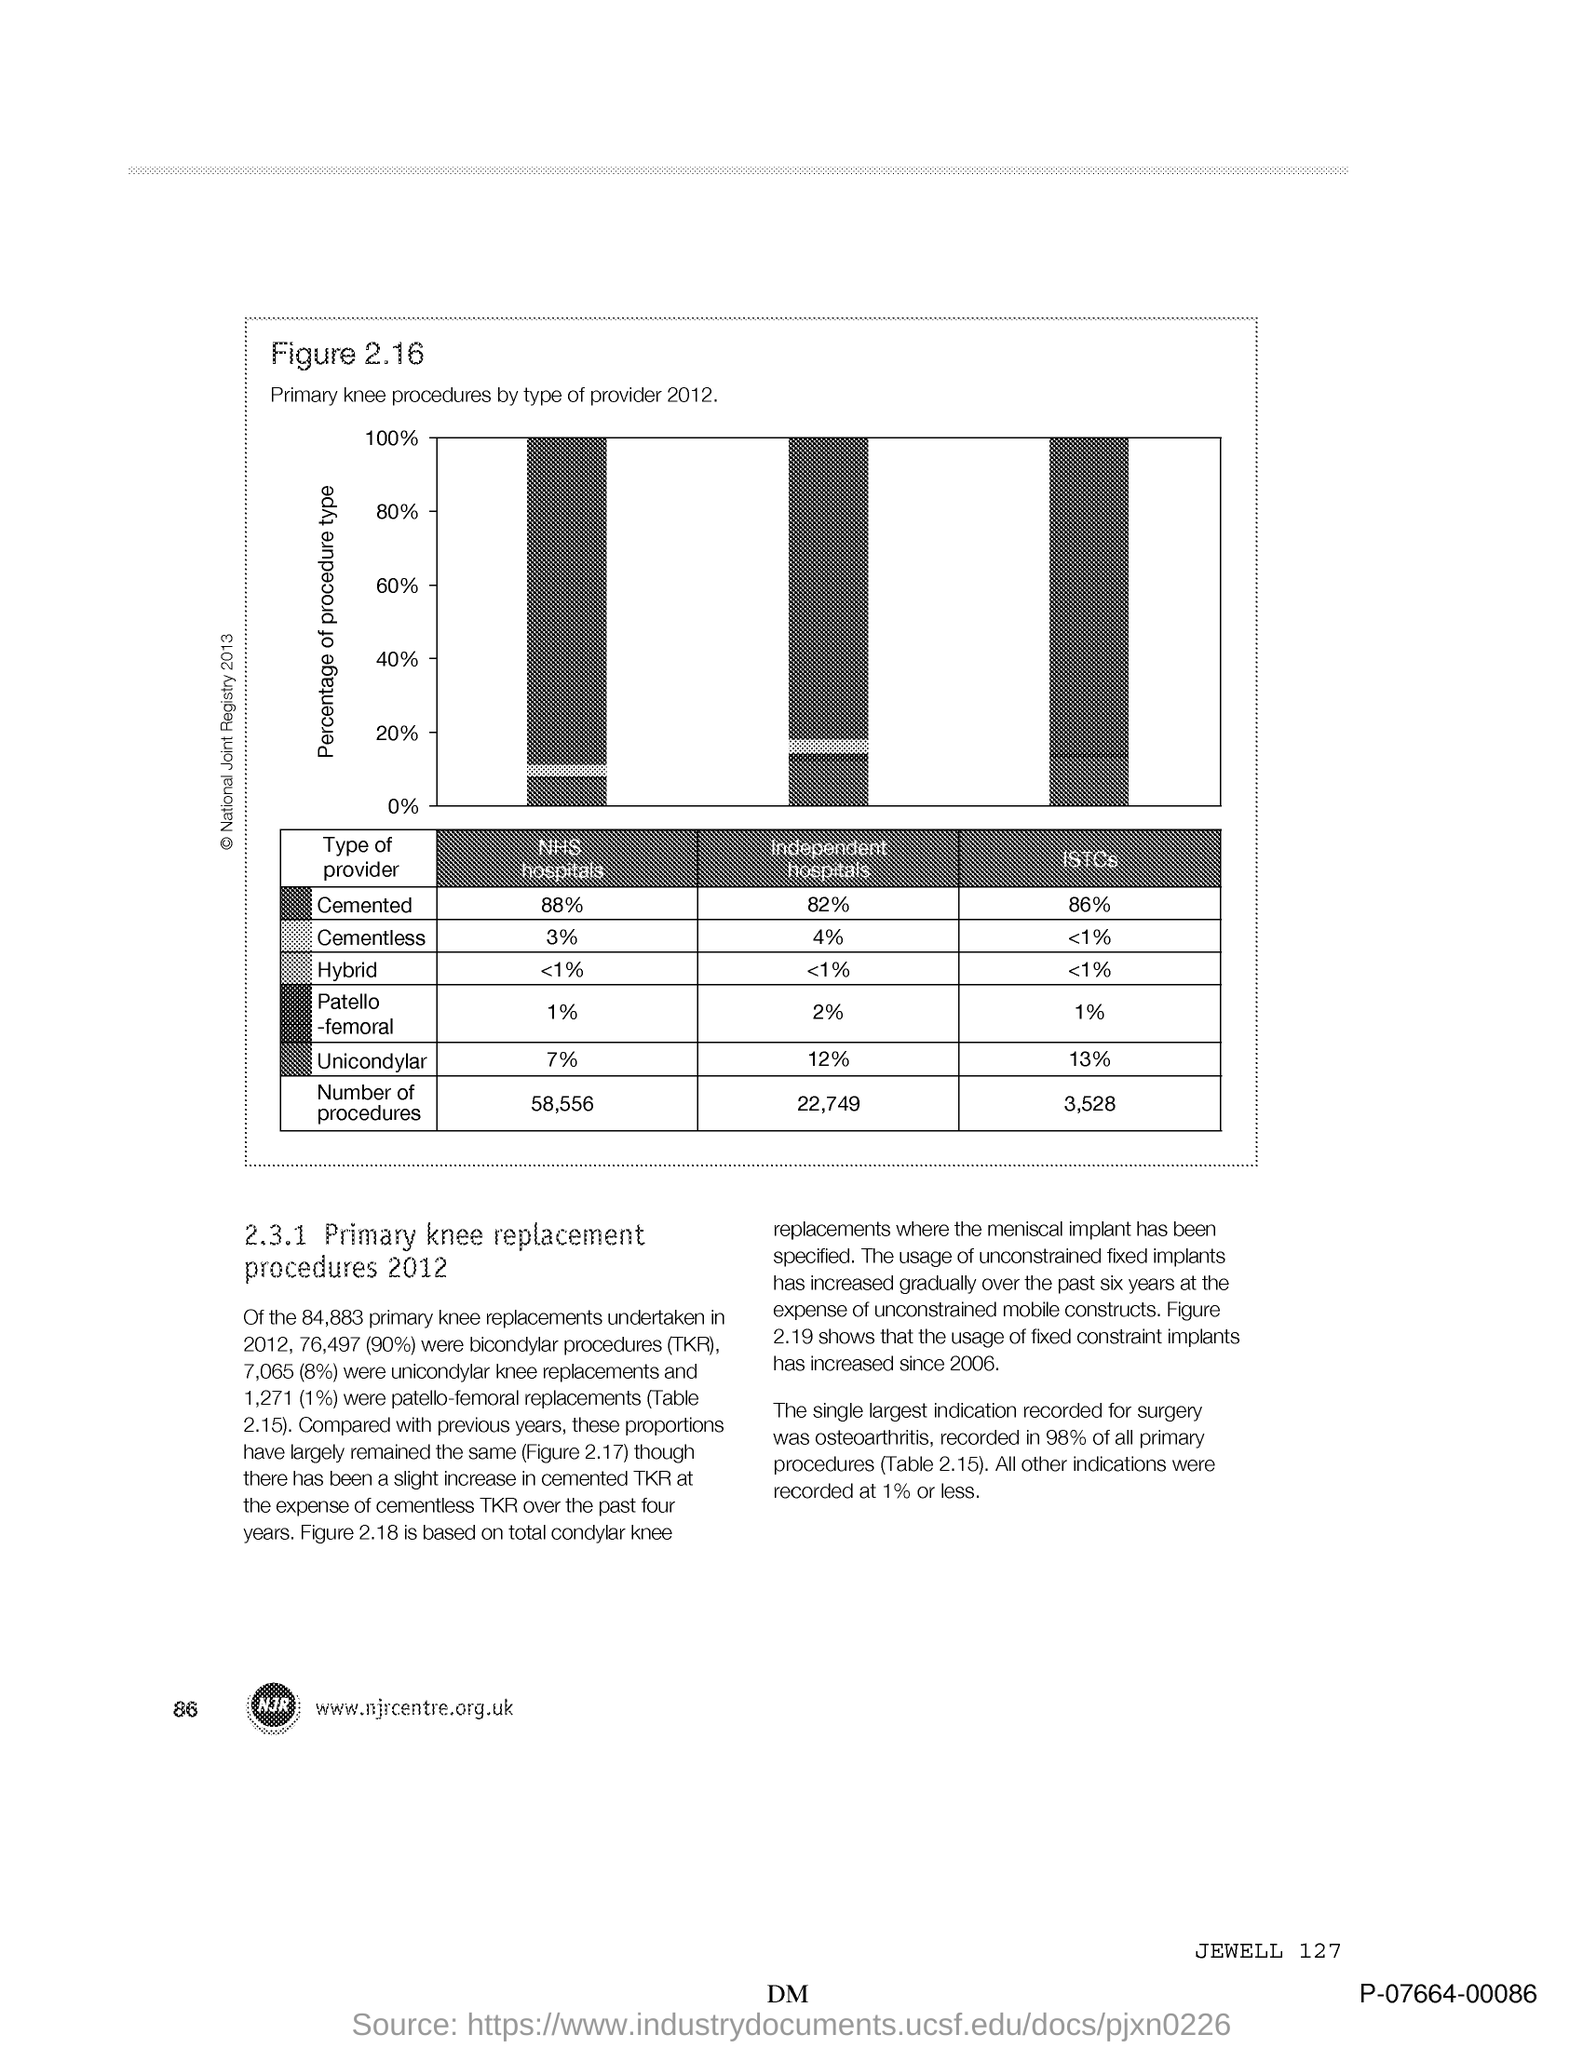Indicate a few pertinent items in this graphic. The y-axis shows the percentage of procedure types. 